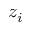<formula> <loc_0><loc_0><loc_500><loc_500>z _ { i }</formula> 